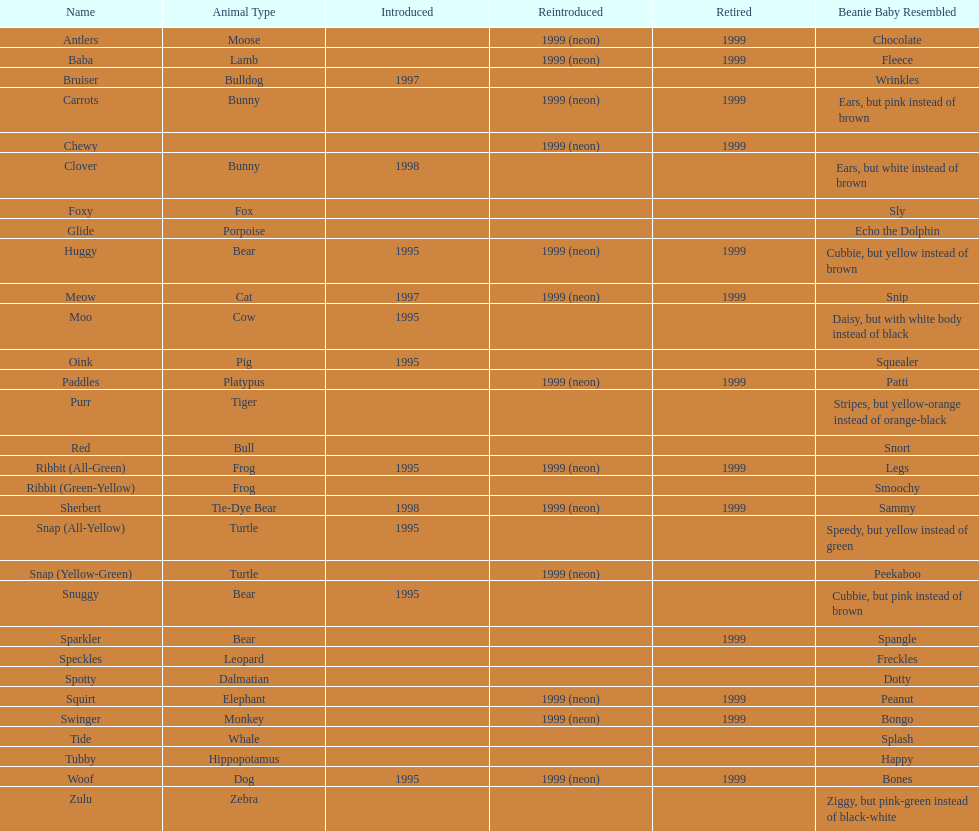Help me parse the entirety of this table. {'header': ['Name', 'Animal Type', 'Introduced', 'Reintroduced', 'Retired', 'Beanie Baby Resembled'], 'rows': [['Antlers', 'Moose', '', '1999 (neon)', '1999', 'Chocolate'], ['Baba', 'Lamb', '', '1999 (neon)', '1999', 'Fleece'], ['Bruiser', 'Bulldog', '1997', '', '', 'Wrinkles'], ['Carrots', 'Bunny', '', '1999 (neon)', '1999', 'Ears, but pink instead of brown'], ['Chewy', '', '', '1999 (neon)', '1999', ''], ['Clover', 'Bunny', '1998', '', '', 'Ears, but white instead of brown'], ['Foxy', 'Fox', '', '', '', 'Sly'], ['Glide', 'Porpoise', '', '', '', 'Echo the Dolphin'], ['Huggy', 'Bear', '1995', '1999 (neon)', '1999', 'Cubbie, but yellow instead of brown'], ['Meow', 'Cat', '1997', '1999 (neon)', '1999', 'Snip'], ['Moo', 'Cow', '1995', '', '', 'Daisy, but with white body instead of black'], ['Oink', 'Pig', '1995', '', '', 'Squealer'], ['Paddles', 'Platypus', '', '1999 (neon)', '1999', 'Patti'], ['Purr', 'Tiger', '', '', '', 'Stripes, but yellow-orange instead of orange-black'], ['Red', 'Bull', '', '', '', 'Snort'], ['Ribbit (All-Green)', 'Frog', '1995', '1999 (neon)', '1999', 'Legs'], ['Ribbit (Green-Yellow)', 'Frog', '', '', '', 'Smoochy'], ['Sherbert', 'Tie-Dye Bear', '1998', '1999 (neon)', '1999', 'Sammy'], ['Snap (All-Yellow)', 'Turtle', '1995', '', '', 'Speedy, but yellow instead of green'], ['Snap (Yellow-Green)', 'Turtle', '', '1999 (neon)', '', 'Peekaboo'], ['Snuggy', 'Bear', '1995', '', '', 'Cubbie, but pink instead of brown'], ['Sparkler', 'Bear', '', '', '1999', 'Spangle'], ['Speckles', 'Leopard', '', '', '', 'Freckles'], ['Spotty', 'Dalmatian', '', '', '', 'Dotty'], ['Squirt', 'Elephant', '', '1999 (neon)', '1999', 'Peanut'], ['Swinger', 'Monkey', '', '1999 (neon)', '1999', 'Bongo'], ['Tide', 'Whale', '', '', '', 'Splash'], ['Tubby', 'Hippopotamus', '', '', '', 'Happy'], ['Woof', 'Dog', '1995', '1999 (neon)', '1999', 'Bones'], ['Zulu', 'Zebra', '', '', '', 'Ziggy, but pink-green instead of black-white']]} How many monkey pillow pals were there? 1. 